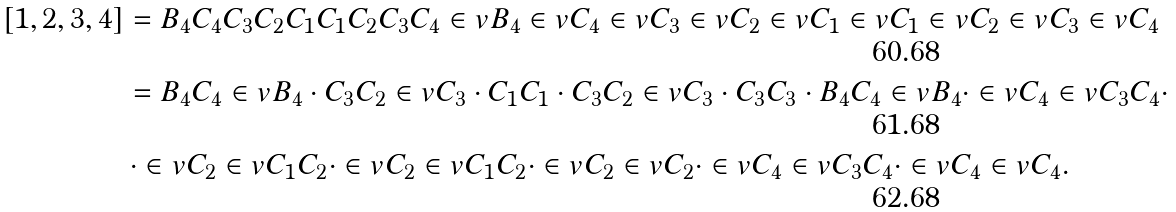Convert formula to latex. <formula><loc_0><loc_0><loc_500><loc_500>[ 1 , 2 , 3 , 4 ] & = B _ { 4 } C _ { 4 } C _ { 3 } C _ { 2 } C _ { 1 } C _ { 1 } C _ { 2 } C _ { 3 } C _ { 4 } \in v { B _ { 4 } } \in v { C _ { 4 } } \in v { C _ { 3 } } \in v { C _ { 2 } } \in v { C _ { 1 } } \in v { C _ { 1 } } \in v { C _ { 2 } } \in v { C _ { 3 } } \in v { C _ { 4 } } \\ & = B _ { 4 } C _ { 4 } \in v { B _ { 4 } } \cdot C _ { 3 } C _ { 2 } \in v { C _ { 3 } } \cdot C _ { 1 } C _ { 1 } \cdot C _ { 3 } C _ { 2 } \in v { C _ { 3 } } \cdot C _ { 3 } C _ { 3 } \cdot B _ { 4 } C _ { 4 } \in v { B _ { 4 } } \cdot \in v { C _ { 4 } } \in v { C _ { 3 } } C _ { 4 } \cdot \\ & \, \cdot \in v { C _ { 2 } } \in v { C _ { 1 } } C _ { 2 } \cdot \in v { C _ { 2 } } \in v { C _ { 1 } } C _ { 2 } \cdot \in v { C _ { 2 } } \in v { C _ { 2 } } \cdot \in v { C _ { 4 } } \in v { C _ { 3 } } C _ { 4 } \cdot \in v { C _ { 4 } } \in v { C _ { 4 } } .</formula> 